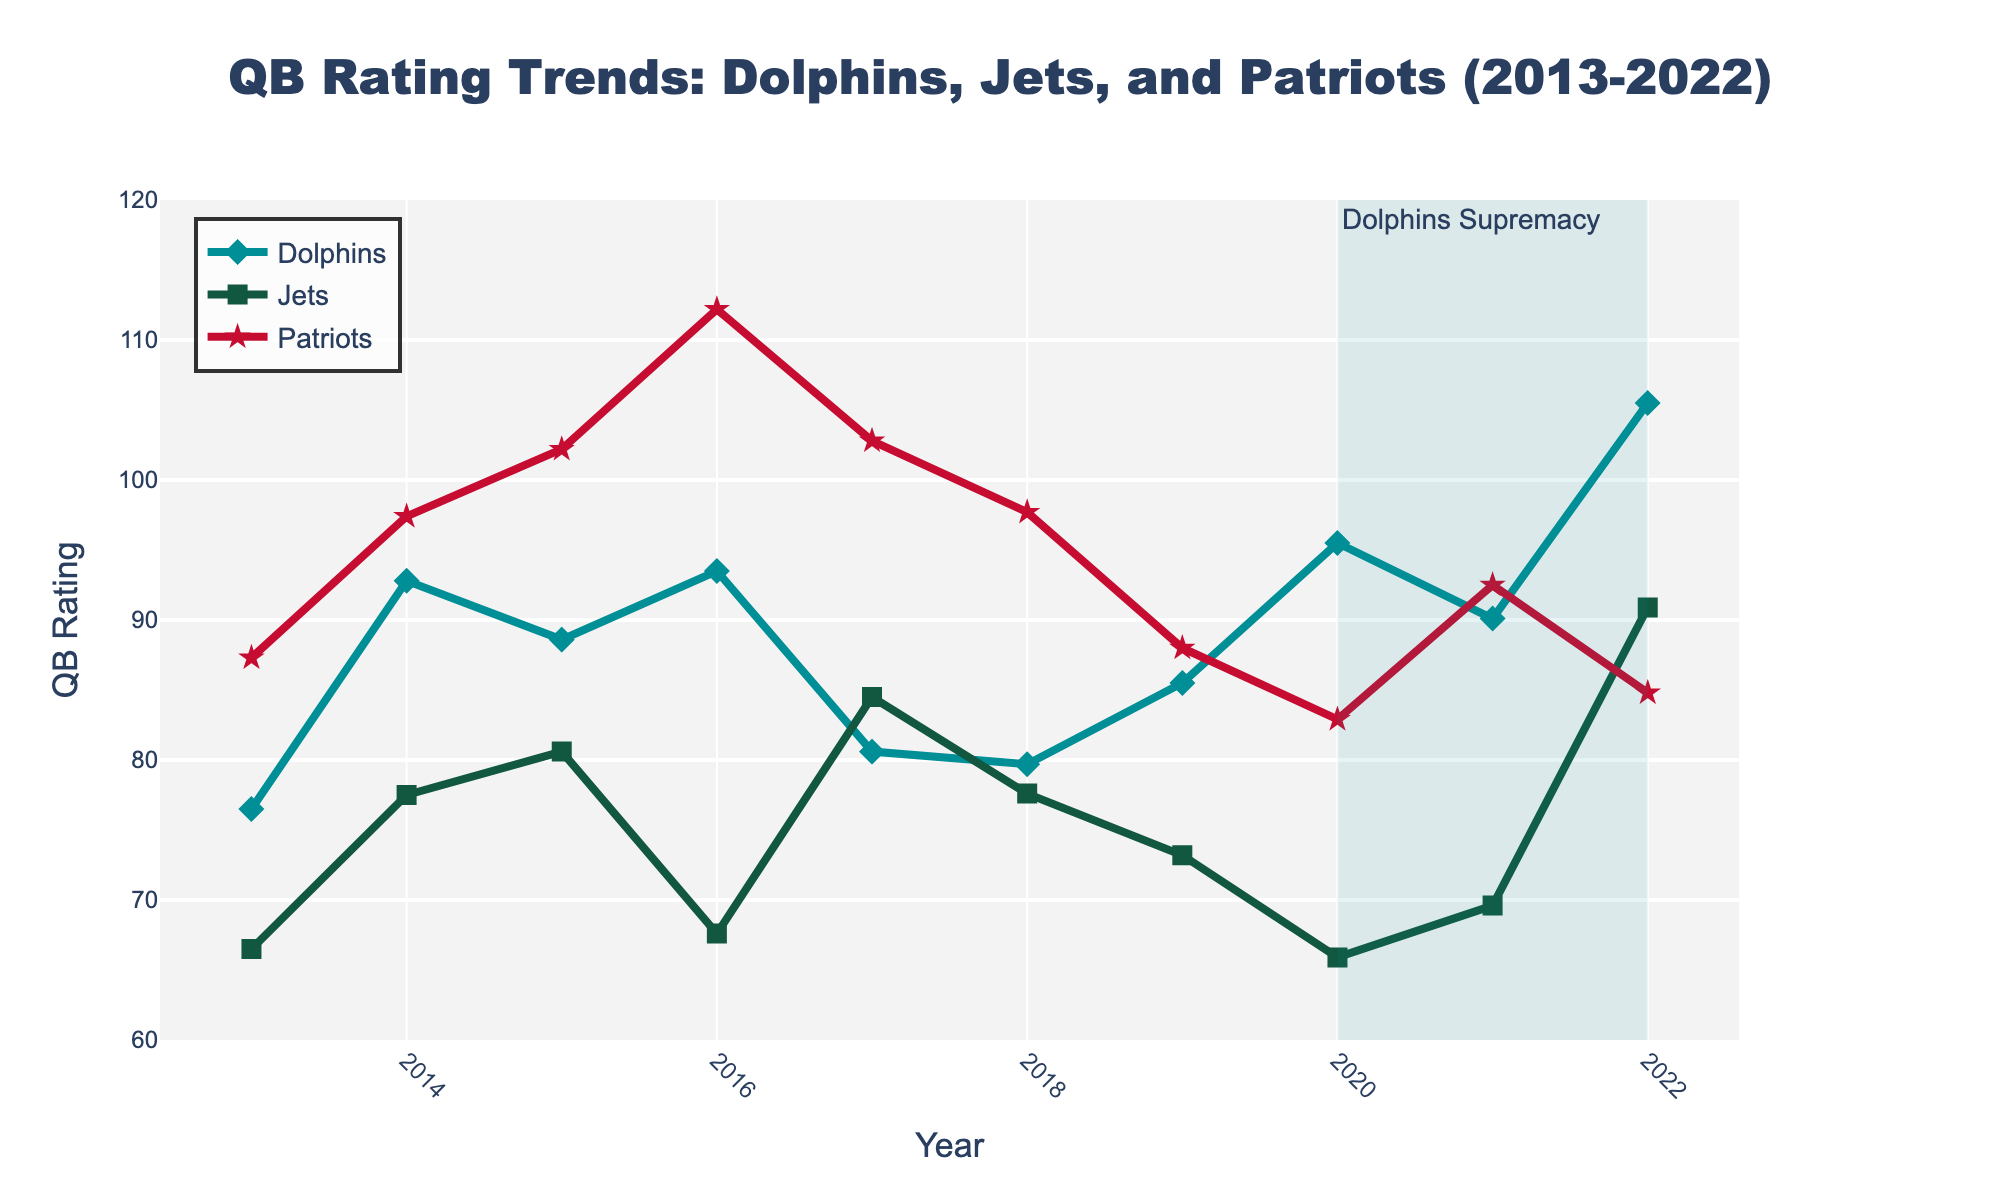What year did the Dolphins' QB have the highest rating? The Dolphins' QB rating is highest in 2022, as indicated by the highest point on the Dolphins' line (blue diamond markers) in that year.
Answer: 2022 Which team had the lowest QB rating in 2020? By examining the lines corresponding to each team for the year 2020, the lowest point is the Jets' rating (green square markers).
Answer: Jets How much did the Patriots' QB rating drop from 2017 to 2018? Patriots' QB rating in 2017 was 102.8, and in 2018 it was 97.7. The drop is calculated as 102.8 - 97.7 = 5.1.
Answer: 5.1 During which years did the Dolphins' QB rating surpass both the Jets' and the Patriots' ratings simultaneously? For each year, the Dolphins' rating needs to be higher than both the Jets' and Patriots' ratings. This happens in 2020 and 2022.
Answer: 2020 and 2022 What is the average QB rating of the Dolphins between 2018 and 2022? Calculate the average by summing the ratings from 2018 to 2022 and then dividing by the number of years: (79.7 + 85.5 + 95.5 + 90.1 + 105.5) / 5 = 91.26.
Answer: 91.26 Which team had the most significant improvement in QB rating from 2019 to 2020? Comparing the changes: Dolphins improved from 85.5 to 95.5 (+10), Jets from 73.2 to 65.9 (-7.3), and Patriots from 88.0 to 82.9 (-5.1). Dolphins had the most significant improvement.
Answer: Dolphins How does the Jets’ QB rating in 2022 compare to their rating in 2013? The rating in 2022 is 90.9 while in 2013 it was 66.5. Comparing these, 90.9 is greater than 66.5.
Answer: Greater What is the combined total QB rating of all three teams in 2016? Sum of ratings in 2016 for Dolphins, Jets, and Patriots: 93.5 + 67.6 + 112.2 = 273.3.
Answer: 273.3 What color and shape represent the Dolphins QB rating line in the figure? The Dolphins QB rating line is represented by a blue line with diamond markers.
Answer: Blue and diamond 